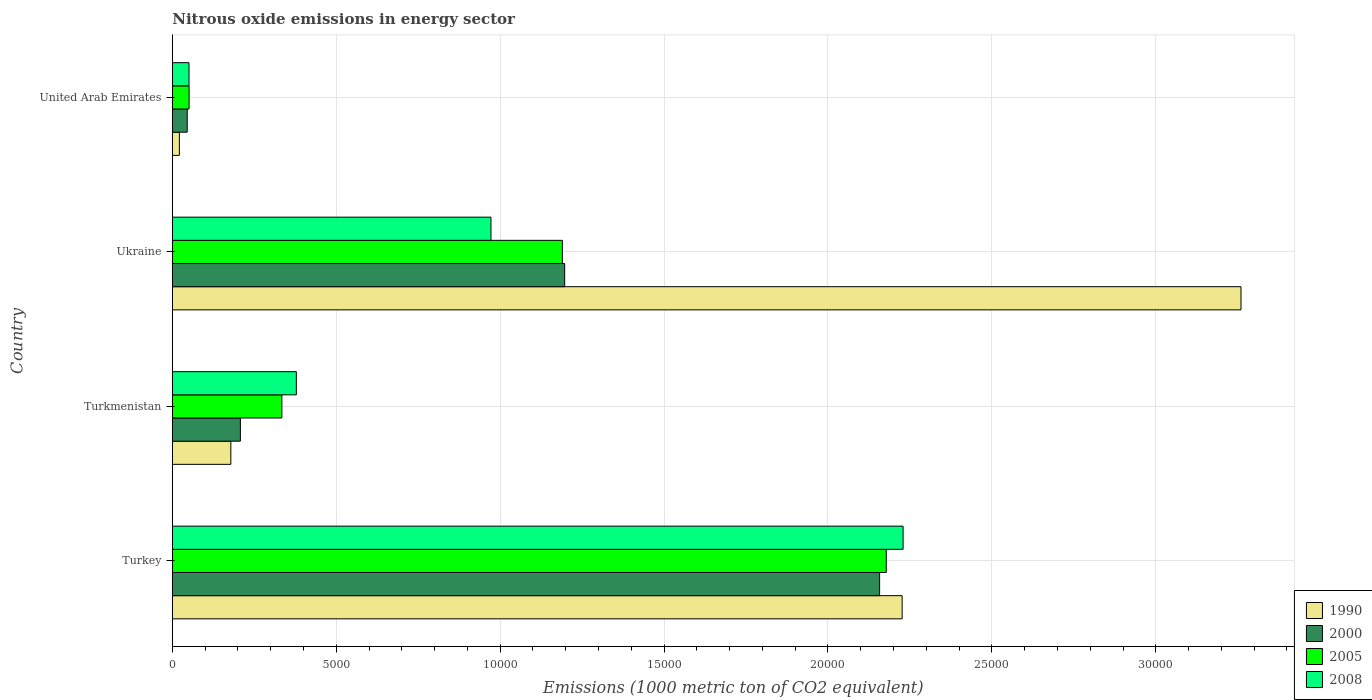How many different coloured bars are there?
Your answer should be compact. 4. Are the number of bars per tick equal to the number of legend labels?
Provide a short and direct response. Yes. How many bars are there on the 1st tick from the top?
Your answer should be very brief. 4. How many bars are there on the 2nd tick from the bottom?
Your response must be concise. 4. What is the label of the 3rd group of bars from the top?
Provide a succinct answer. Turkmenistan. In how many cases, is the number of bars for a given country not equal to the number of legend labels?
Ensure brevity in your answer.  0. What is the amount of nitrous oxide emitted in 2000 in Turkey?
Provide a short and direct response. 2.16e+04. Across all countries, what is the maximum amount of nitrous oxide emitted in 2008?
Ensure brevity in your answer.  2.23e+04. Across all countries, what is the minimum amount of nitrous oxide emitted in 1990?
Make the answer very short. 214.5. In which country was the amount of nitrous oxide emitted in 1990 maximum?
Ensure brevity in your answer.  Ukraine. In which country was the amount of nitrous oxide emitted in 2008 minimum?
Keep it short and to the point. United Arab Emirates. What is the total amount of nitrous oxide emitted in 2000 in the graph?
Keep it short and to the point. 3.61e+04. What is the difference between the amount of nitrous oxide emitted in 2000 in Ukraine and that in United Arab Emirates?
Offer a very short reply. 1.15e+04. What is the difference between the amount of nitrous oxide emitted in 2005 in Ukraine and the amount of nitrous oxide emitted in 2000 in Turkmenistan?
Offer a terse response. 9822.2. What is the average amount of nitrous oxide emitted in 1990 per country?
Provide a short and direct response. 1.42e+04. What is the difference between the amount of nitrous oxide emitted in 1990 and amount of nitrous oxide emitted in 2000 in Turkmenistan?
Ensure brevity in your answer.  -290.8. What is the ratio of the amount of nitrous oxide emitted in 2000 in Turkmenistan to that in United Arab Emirates?
Your answer should be very brief. 4.58. Is the amount of nitrous oxide emitted in 2005 in Turkey less than that in United Arab Emirates?
Provide a succinct answer. No. What is the difference between the highest and the second highest amount of nitrous oxide emitted in 1990?
Keep it short and to the point. 1.03e+04. What is the difference between the highest and the lowest amount of nitrous oxide emitted in 1990?
Provide a succinct answer. 3.24e+04. In how many countries, is the amount of nitrous oxide emitted in 2005 greater than the average amount of nitrous oxide emitted in 2005 taken over all countries?
Provide a succinct answer. 2. Is the sum of the amount of nitrous oxide emitted in 1990 in Turkmenistan and United Arab Emirates greater than the maximum amount of nitrous oxide emitted in 2005 across all countries?
Provide a succinct answer. No. Is it the case that in every country, the sum of the amount of nitrous oxide emitted in 2005 and amount of nitrous oxide emitted in 2000 is greater than the sum of amount of nitrous oxide emitted in 2008 and amount of nitrous oxide emitted in 1990?
Offer a very short reply. No. How many bars are there?
Your answer should be compact. 16. How many countries are there in the graph?
Your answer should be very brief. 4. What is the difference between two consecutive major ticks on the X-axis?
Provide a succinct answer. 5000. How are the legend labels stacked?
Provide a short and direct response. Vertical. What is the title of the graph?
Your response must be concise. Nitrous oxide emissions in energy sector. What is the label or title of the X-axis?
Provide a succinct answer. Emissions (1000 metric ton of CO2 equivalent). What is the Emissions (1000 metric ton of CO2 equivalent) in 1990 in Turkey?
Offer a terse response. 2.23e+04. What is the Emissions (1000 metric ton of CO2 equivalent) in 2000 in Turkey?
Your response must be concise. 2.16e+04. What is the Emissions (1000 metric ton of CO2 equivalent) of 2005 in Turkey?
Your answer should be very brief. 2.18e+04. What is the Emissions (1000 metric ton of CO2 equivalent) of 2008 in Turkey?
Your answer should be compact. 2.23e+04. What is the Emissions (1000 metric ton of CO2 equivalent) in 1990 in Turkmenistan?
Your response must be concise. 1784.5. What is the Emissions (1000 metric ton of CO2 equivalent) in 2000 in Turkmenistan?
Offer a terse response. 2075.3. What is the Emissions (1000 metric ton of CO2 equivalent) of 2005 in Turkmenistan?
Provide a succinct answer. 3341.3. What is the Emissions (1000 metric ton of CO2 equivalent) in 2008 in Turkmenistan?
Your answer should be compact. 3782.4. What is the Emissions (1000 metric ton of CO2 equivalent) in 1990 in Ukraine?
Provide a short and direct response. 3.26e+04. What is the Emissions (1000 metric ton of CO2 equivalent) in 2000 in Ukraine?
Provide a succinct answer. 1.20e+04. What is the Emissions (1000 metric ton of CO2 equivalent) of 2005 in Ukraine?
Your answer should be compact. 1.19e+04. What is the Emissions (1000 metric ton of CO2 equivalent) in 2008 in Ukraine?
Your response must be concise. 9719.1. What is the Emissions (1000 metric ton of CO2 equivalent) in 1990 in United Arab Emirates?
Your answer should be compact. 214.5. What is the Emissions (1000 metric ton of CO2 equivalent) in 2000 in United Arab Emirates?
Provide a short and direct response. 453.6. What is the Emissions (1000 metric ton of CO2 equivalent) of 2005 in United Arab Emirates?
Give a very brief answer. 510.2. What is the Emissions (1000 metric ton of CO2 equivalent) of 2008 in United Arab Emirates?
Your answer should be compact. 507.7. Across all countries, what is the maximum Emissions (1000 metric ton of CO2 equivalent) in 1990?
Your answer should be compact. 3.26e+04. Across all countries, what is the maximum Emissions (1000 metric ton of CO2 equivalent) of 2000?
Provide a short and direct response. 2.16e+04. Across all countries, what is the maximum Emissions (1000 metric ton of CO2 equivalent) of 2005?
Your answer should be very brief. 2.18e+04. Across all countries, what is the maximum Emissions (1000 metric ton of CO2 equivalent) in 2008?
Provide a short and direct response. 2.23e+04. Across all countries, what is the minimum Emissions (1000 metric ton of CO2 equivalent) in 1990?
Give a very brief answer. 214.5. Across all countries, what is the minimum Emissions (1000 metric ton of CO2 equivalent) in 2000?
Your answer should be very brief. 453.6. Across all countries, what is the minimum Emissions (1000 metric ton of CO2 equivalent) in 2005?
Provide a succinct answer. 510.2. Across all countries, what is the minimum Emissions (1000 metric ton of CO2 equivalent) in 2008?
Your answer should be compact. 507.7. What is the total Emissions (1000 metric ton of CO2 equivalent) in 1990 in the graph?
Your answer should be very brief. 5.69e+04. What is the total Emissions (1000 metric ton of CO2 equivalent) in 2000 in the graph?
Offer a very short reply. 3.61e+04. What is the total Emissions (1000 metric ton of CO2 equivalent) of 2005 in the graph?
Give a very brief answer. 3.75e+04. What is the total Emissions (1000 metric ton of CO2 equivalent) in 2008 in the graph?
Offer a terse response. 3.63e+04. What is the difference between the Emissions (1000 metric ton of CO2 equivalent) of 1990 in Turkey and that in Turkmenistan?
Ensure brevity in your answer.  2.05e+04. What is the difference between the Emissions (1000 metric ton of CO2 equivalent) of 2000 in Turkey and that in Turkmenistan?
Your response must be concise. 1.95e+04. What is the difference between the Emissions (1000 metric ton of CO2 equivalent) in 2005 in Turkey and that in Turkmenistan?
Keep it short and to the point. 1.84e+04. What is the difference between the Emissions (1000 metric ton of CO2 equivalent) in 2008 in Turkey and that in Turkmenistan?
Provide a short and direct response. 1.85e+04. What is the difference between the Emissions (1000 metric ton of CO2 equivalent) in 1990 in Turkey and that in Ukraine?
Your response must be concise. -1.03e+04. What is the difference between the Emissions (1000 metric ton of CO2 equivalent) in 2000 in Turkey and that in Ukraine?
Ensure brevity in your answer.  9607.4. What is the difference between the Emissions (1000 metric ton of CO2 equivalent) in 2005 in Turkey and that in Ukraine?
Your answer should be compact. 9880.3. What is the difference between the Emissions (1000 metric ton of CO2 equivalent) in 2008 in Turkey and that in Ukraine?
Offer a terse response. 1.26e+04. What is the difference between the Emissions (1000 metric ton of CO2 equivalent) in 1990 in Turkey and that in United Arab Emirates?
Keep it short and to the point. 2.20e+04. What is the difference between the Emissions (1000 metric ton of CO2 equivalent) in 2000 in Turkey and that in United Arab Emirates?
Make the answer very short. 2.11e+04. What is the difference between the Emissions (1000 metric ton of CO2 equivalent) in 2005 in Turkey and that in United Arab Emirates?
Offer a very short reply. 2.13e+04. What is the difference between the Emissions (1000 metric ton of CO2 equivalent) of 2008 in Turkey and that in United Arab Emirates?
Offer a very short reply. 2.18e+04. What is the difference between the Emissions (1000 metric ton of CO2 equivalent) of 1990 in Turkmenistan and that in Ukraine?
Ensure brevity in your answer.  -3.08e+04. What is the difference between the Emissions (1000 metric ton of CO2 equivalent) of 2000 in Turkmenistan and that in Ukraine?
Provide a succinct answer. -9892.6. What is the difference between the Emissions (1000 metric ton of CO2 equivalent) of 2005 in Turkmenistan and that in Ukraine?
Your response must be concise. -8556.2. What is the difference between the Emissions (1000 metric ton of CO2 equivalent) of 2008 in Turkmenistan and that in Ukraine?
Keep it short and to the point. -5936.7. What is the difference between the Emissions (1000 metric ton of CO2 equivalent) of 1990 in Turkmenistan and that in United Arab Emirates?
Ensure brevity in your answer.  1570. What is the difference between the Emissions (1000 metric ton of CO2 equivalent) in 2000 in Turkmenistan and that in United Arab Emirates?
Make the answer very short. 1621.7. What is the difference between the Emissions (1000 metric ton of CO2 equivalent) in 2005 in Turkmenistan and that in United Arab Emirates?
Keep it short and to the point. 2831.1. What is the difference between the Emissions (1000 metric ton of CO2 equivalent) of 2008 in Turkmenistan and that in United Arab Emirates?
Provide a succinct answer. 3274.7. What is the difference between the Emissions (1000 metric ton of CO2 equivalent) of 1990 in Ukraine and that in United Arab Emirates?
Ensure brevity in your answer.  3.24e+04. What is the difference between the Emissions (1000 metric ton of CO2 equivalent) of 2000 in Ukraine and that in United Arab Emirates?
Your answer should be very brief. 1.15e+04. What is the difference between the Emissions (1000 metric ton of CO2 equivalent) in 2005 in Ukraine and that in United Arab Emirates?
Your answer should be very brief. 1.14e+04. What is the difference between the Emissions (1000 metric ton of CO2 equivalent) of 2008 in Ukraine and that in United Arab Emirates?
Keep it short and to the point. 9211.4. What is the difference between the Emissions (1000 metric ton of CO2 equivalent) of 1990 in Turkey and the Emissions (1000 metric ton of CO2 equivalent) of 2000 in Turkmenistan?
Provide a succinct answer. 2.02e+04. What is the difference between the Emissions (1000 metric ton of CO2 equivalent) in 1990 in Turkey and the Emissions (1000 metric ton of CO2 equivalent) in 2005 in Turkmenistan?
Ensure brevity in your answer.  1.89e+04. What is the difference between the Emissions (1000 metric ton of CO2 equivalent) in 1990 in Turkey and the Emissions (1000 metric ton of CO2 equivalent) in 2008 in Turkmenistan?
Provide a short and direct response. 1.85e+04. What is the difference between the Emissions (1000 metric ton of CO2 equivalent) of 2000 in Turkey and the Emissions (1000 metric ton of CO2 equivalent) of 2005 in Turkmenistan?
Make the answer very short. 1.82e+04. What is the difference between the Emissions (1000 metric ton of CO2 equivalent) of 2000 in Turkey and the Emissions (1000 metric ton of CO2 equivalent) of 2008 in Turkmenistan?
Offer a terse response. 1.78e+04. What is the difference between the Emissions (1000 metric ton of CO2 equivalent) of 2005 in Turkey and the Emissions (1000 metric ton of CO2 equivalent) of 2008 in Turkmenistan?
Provide a succinct answer. 1.80e+04. What is the difference between the Emissions (1000 metric ton of CO2 equivalent) in 1990 in Turkey and the Emissions (1000 metric ton of CO2 equivalent) in 2000 in Ukraine?
Ensure brevity in your answer.  1.03e+04. What is the difference between the Emissions (1000 metric ton of CO2 equivalent) of 1990 in Turkey and the Emissions (1000 metric ton of CO2 equivalent) of 2005 in Ukraine?
Offer a very short reply. 1.04e+04. What is the difference between the Emissions (1000 metric ton of CO2 equivalent) of 1990 in Turkey and the Emissions (1000 metric ton of CO2 equivalent) of 2008 in Ukraine?
Ensure brevity in your answer.  1.25e+04. What is the difference between the Emissions (1000 metric ton of CO2 equivalent) of 2000 in Turkey and the Emissions (1000 metric ton of CO2 equivalent) of 2005 in Ukraine?
Provide a short and direct response. 9677.8. What is the difference between the Emissions (1000 metric ton of CO2 equivalent) of 2000 in Turkey and the Emissions (1000 metric ton of CO2 equivalent) of 2008 in Ukraine?
Give a very brief answer. 1.19e+04. What is the difference between the Emissions (1000 metric ton of CO2 equivalent) in 2005 in Turkey and the Emissions (1000 metric ton of CO2 equivalent) in 2008 in Ukraine?
Ensure brevity in your answer.  1.21e+04. What is the difference between the Emissions (1000 metric ton of CO2 equivalent) of 1990 in Turkey and the Emissions (1000 metric ton of CO2 equivalent) of 2000 in United Arab Emirates?
Your answer should be very brief. 2.18e+04. What is the difference between the Emissions (1000 metric ton of CO2 equivalent) in 1990 in Turkey and the Emissions (1000 metric ton of CO2 equivalent) in 2005 in United Arab Emirates?
Your answer should be very brief. 2.18e+04. What is the difference between the Emissions (1000 metric ton of CO2 equivalent) of 1990 in Turkey and the Emissions (1000 metric ton of CO2 equivalent) of 2008 in United Arab Emirates?
Offer a terse response. 2.18e+04. What is the difference between the Emissions (1000 metric ton of CO2 equivalent) in 2000 in Turkey and the Emissions (1000 metric ton of CO2 equivalent) in 2005 in United Arab Emirates?
Your answer should be very brief. 2.11e+04. What is the difference between the Emissions (1000 metric ton of CO2 equivalent) of 2000 in Turkey and the Emissions (1000 metric ton of CO2 equivalent) of 2008 in United Arab Emirates?
Provide a short and direct response. 2.11e+04. What is the difference between the Emissions (1000 metric ton of CO2 equivalent) in 2005 in Turkey and the Emissions (1000 metric ton of CO2 equivalent) in 2008 in United Arab Emirates?
Offer a very short reply. 2.13e+04. What is the difference between the Emissions (1000 metric ton of CO2 equivalent) in 1990 in Turkmenistan and the Emissions (1000 metric ton of CO2 equivalent) in 2000 in Ukraine?
Give a very brief answer. -1.02e+04. What is the difference between the Emissions (1000 metric ton of CO2 equivalent) in 1990 in Turkmenistan and the Emissions (1000 metric ton of CO2 equivalent) in 2005 in Ukraine?
Ensure brevity in your answer.  -1.01e+04. What is the difference between the Emissions (1000 metric ton of CO2 equivalent) of 1990 in Turkmenistan and the Emissions (1000 metric ton of CO2 equivalent) of 2008 in Ukraine?
Provide a short and direct response. -7934.6. What is the difference between the Emissions (1000 metric ton of CO2 equivalent) of 2000 in Turkmenistan and the Emissions (1000 metric ton of CO2 equivalent) of 2005 in Ukraine?
Your answer should be compact. -9822.2. What is the difference between the Emissions (1000 metric ton of CO2 equivalent) of 2000 in Turkmenistan and the Emissions (1000 metric ton of CO2 equivalent) of 2008 in Ukraine?
Make the answer very short. -7643.8. What is the difference between the Emissions (1000 metric ton of CO2 equivalent) in 2005 in Turkmenistan and the Emissions (1000 metric ton of CO2 equivalent) in 2008 in Ukraine?
Give a very brief answer. -6377.8. What is the difference between the Emissions (1000 metric ton of CO2 equivalent) in 1990 in Turkmenistan and the Emissions (1000 metric ton of CO2 equivalent) in 2000 in United Arab Emirates?
Your answer should be compact. 1330.9. What is the difference between the Emissions (1000 metric ton of CO2 equivalent) of 1990 in Turkmenistan and the Emissions (1000 metric ton of CO2 equivalent) of 2005 in United Arab Emirates?
Your answer should be compact. 1274.3. What is the difference between the Emissions (1000 metric ton of CO2 equivalent) in 1990 in Turkmenistan and the Emissions (1000 metric ton of CO2 equivalent) in 2008 in United Arab Emirates?
Provide a succinct answer. 1276.8. What is the difference between the Emissions (1000 metric ton of CO2 equivalent) of 2000 in Turkmenistan and the Emissions (1000 metric ton of CO2 equivalent) of 2005 in United Arab Emirates?
Provide a succinct answer. 1565.1. What is the difference between the Emissions (1000 metric ton of CO2 equivalent) in 2000 in Turkmenistan and the Emissions (1000 metric ton of CO2 equivalent) in 2008 in United Arab Emirates?
Offer a terse response. 1567.6. What is the difference between the Emissions (1000 metric ton of CO2 equivalent) in 2005 in Turkmenistan and the Emissions (1000 metric ton of CO2 equivalent) in 2008 in United Arab Emirates?
Provide a succinct answer. 2833.6. What is the difference between the Emissions (1000 metric ton of CO2 equivalent) of 1990 in Ukraine and the Emissions (1000 metric ton of CO2 equivalent) of 2000 in United Arab Emirates?
Your response must be concise. 3.21e+04. What is the difference between the Emissions (1000 metric ton of CO2 equivalent) of 1990 in Ukraine and the Emissions (1000 metric ton of CO2 equivalent) of 2005 in United Arab Emirates?
Provide a succinct answer. 3.21e+04. What is the difference between the Emissions (1000 metric ton of CO2 equivalent) of 1990 in Ukraine and the Emissions (1000 metric ton of CO2 equivalent) of 2008 in United Arab Emirates?
Your answer should be compact. 3.21e+04. What is the difference between the Emissions (1000 metric ton of CO2 equivalent) in 2000 in Ukraine and the Emissions (1000 metric ton of CO2 equivalent) in 2005 in United Arab Emirates?
Your answer should be compact. 1.15e+04. What is the difference between the Emissions (1000 metric ton of CO2 equivalent) in 2000 in Ukraine and the Emissions (1000 metric ton of CO2 equivalent) in 2008 in United Arab Emirates?
Offer a very short reply. 1.15e+04. What is the difference between the Emissions (1000 metric ton of CO2 equivalent) of 2005 in Ukraine and the Emissions (1000 metric ton of CO2 equivalent) of 2008 in United Arab Emirates?
Keep it short and to the point. 1.14e+04. What is the average Emissions (1000 metric ton of CO2 equivalent) in 1990 per country?
Your response must be concise. 1.42e+04. What is the average Emissions (1000 metric ton of CO2 equivalent) of 2000 per country?
Offer a terse response. 9018.02. What is the average Emissions (1000 metric ton of CO2 equivalent) in 2005 per country?
Offer a terse response. 9381.7. What is the average Emissions (1000 metric ton of CO2 equivalent) in 2008 per country?
Provide a succinct answer. 9075.23. What is the difference between the Emissions (1000 metric ton of CO2 equivalent) in 1990 and Emissions (1000 metric ton of CO2 equivalent) in 2000 in Turkey?
Offer a very short reply. 687.6. What is the difference between the Emissions (1000 metric ton of CO2 equivalent) of 1990 and Emissions (1000 metric ton of CO2 equivalent) of 2005 in Turkey?
Your answer should be very brief. 485.1. What is the difference between the Emissions (1000 metric ton of CO2 equivalent) in 1990 and Emissions (1000 metric ton of CO2 equivalent) in 2008 in Turkey?
Provide a short and direct response. -28.8. What is the difference between the Emissions (1000 metric ton of CO2 equivalent) in 2000 and Emissions (1000 metric ton of CO2 equivalent) in 2005 in Turkey?
Give a very brief answer. -202.5. What is the difference between the Emissions (1000 metric ton of CO2 equivalent) of 2000 and Emissions (1000 metric ton of CO2 equivalent) of 2008 in Turkey?
Give a very brief answer. -716.4. What is the difference between the Emissions (1000 metric ton of CO2 equivalent) in 2005 and Emissions (1000 metric ton of CO2 equivalent) in 2008 in Turkey?
Your response must be concise. -513.9. What is the difference between the Emissions (1000 metric ton of CO2 equivalent) of 1990 and Emissions (1000 metric ton of CO2 equivalent) of 2000 in Turkmenistan?
Your response must be concise. -290.8. What is the difference between the Emissions (1000 metric ton of CO2 equivalent) of 1990 and Emissions (1000 metric ton of CO2 equivalent) of 2005 in Turkmenistan?
Provide a short and direct response. -1556.8. What is the difference between the Emissions (1000 metric ton of CO2 equivalent) of 1990 and Emissions (1000 metric ton of CO2 equivalent) of 2008 in Turkmenistan?
Your answer should be very brief. -1997.9. What is the difference between the Emissions (1000 metric ton of CO2 equivalent) of 2000 and Emissions (1000 metric ton of CO2 equivalent) of 2005 in Turkmenistan?
Give a very brief answer. -1266. What is the difference between the Emissions (1000 metric ton of CO2 equivalent) of 2000 and Emissions (1000 metric ton of CO2 equivalent) of 2008 in Turkmenistan?
Provide a succinct answer. -1707.1. What is the difference between the Emissions (1000 metric ton of CO2 equivalent) of 2005 and Emissions (1000 metric ton of CO2 equivalent) of 2008 in Turkmenistan?
Offer a very short reply. -441.1. What is the difference between the Emissions (1000 metric ton of CO2 equivalent) of 1990 and Emissions (1000 metric ton of CO2 equivalent) of 2000 in Ukraine?
Provide a succinct answer. 2.06e+04. What is the difference between the Emissions (1000 metric ton of CO2 equivalent) of 1990 and Emissions (1000 metric ton of CO2 equivalent) of 2005 in Ukraine?
Keep it short and to the point. 2.07e+04. What is the difference between the Emissions (1000 metric ton of CO2 equivalent) of 1990 and Emissions (1000 metric ton of CO2 equivalent) of 2008 in Ukraine?
Make the answer very short. 2.29e+04. What is the difference between the Emissions (1000 metric ton of CO2 equivalent) of 2000 and Emissions (1000 metric ton of CO2 equivalent) of 2005 in Ukraine?
Ensure brevity in your answer.  70.4. What is the difference between the Emissions (1000 metric ton of CO2 equivalent) of 2000 and Emissions (1000 metric ton of CO2 equivalent) of 2008 in Ukraine?
Your answer should be compact. 2248.8. What is the difference between the Emissions (1000 metric ton of CO2 equivalent) of 2005 and Emissions (1000 metric ton of CO2 equivalent) of 2008 in Ukraine?
Provide a short and direct response. 2178.4. What is the difference between the Emissions (1000 metric ton of CO2 equivalent) in 1990 and Emissions (1000 metric ton of CO2 equivalent) in 2000 in United Arab Emirates?
Your answer should be very brief. -239.1. What is the difference between the Emissions (1000 metric ton of CO2 equivalent) in 1990 and Emissions (1000 metric ton of CO2 equivalent) in 2005 in United Arab Emirates?
Make the answer very short. -295.7. What is the difference between the Emissions (1000 metric ton of CO2 equivalent) of 1990 and Emissions (1000 metric ton of CO2 equivalent) of 2008 in United Arab Emirates?
Your response must be concise. -293.2. What is the difference between the Emissions (1000 metric ton of CO2 equivalent) of 2000 and Emissions (1000 metric ton of CO2 equivalent) of 2005 in United Arab Emirates?
Your response must be concise. -56.6. What is the difference between the Emissions (1000 metric ton of CO2 equivalent) of 2000 and Emissions (1000 metric ton of CO2 equivalent) of 2008 in United Arab Emirates?
Your answer should be compact. -54.1. What is the difference between the Emissions (1000 metric ton of CO2 equivalent) of 2005 and Emissions (1000 metric ton of CO2 equivalent) of 2008 in United Arab Emirates?
Provide a short and direct response. 2.5. What is the ratio of the Emissions (1000 metric ton of CO2 equivalent) in 1990 in Turkey to that in Turkmenistan?
Ensure brevity in your answer.  12.48. What is the ratio of the Emissions (1000 metric ton of CO2 equivalent) in 2000 in Turkey to that in Turkmenistan?
Offer a very short reply. 10.4. What is the ratio of the Emissions (1000 metric ton of CO2 equivalent) in 2005 in Turkey to that in Turkmenistan?
Your response must be concise. 6.52. What is the ratio of the Emissions (1000 metric ton of CO2 equivalent) in 2008 in Turkey to that in Turkmenistan?
Ensure brevity in your answer.  5.89. What is the ratio of the Emissions (1000 metric ton of CO2 equivalent) in 1990 in Turkey to that in Ukraine?
Your answer should be very brief. 0.68. What is the ratio of the Emissions (1000 metric ton of CO2 equivalent) in 2000 in Turkey to that in Ukraine?
Offer a very short reply. 1.8. What is the ratio of the Emissions (1000 metric ton of CO2 equivalent) in 2005 in Turkey to that in Ukraine?
Your answer should be very brief. 1.83. What is the ratio of the Emissions (1000 metric ton of CO2 equivalent) of 2008 in Turkey to that in Ukraine?
Offer a terse response. 2.29. What is the ratio of the Emissions (1000 metric ton of CO2 equivalent) of 1990 in Turkey to that in United Arab Emirates?
Keep it short and to the point. 103.79. What is the ratio of the Emissions (1000 metric ton of CO2 equivalent) of 2000 in Turkey to that in United Arab Emirates?
Provide a short and direct response. 47.56. What is the ratio of the Emissions (1000 metric ton of CO2 equivalent) in 2005 in Turkey to that in United Arab Emirates?
Keep it short and to the point. 42.68. What is the ratio of the Emissions (1000 metric ton of CO2 equivalent) in 2008 in Turkey to that in United Arab Emirates?
Offer a terse response. 43.91. What is the ratio of the Emissions (1000 metric ton of CO2 equivalent) in 1990 in Turkmenistan to that in Ukraine?
Offer a terse response. 0.05. What is the ratio of the Emissions (1000 metric ton of CO2 equivalent) of 2000 in Turkmenistan to that in Ukraine?
Ensure brevity in your answer.  0.17. What is the ratio of the Emissions (1000 metric ton of CO2 equivalent) in 2005 in Turkmenistan to that in Ukraine?
Your answer should be very brief. 0.28. What is the ratio of the Emissions (1000 metric ton of CO2 equivalent) of 2008 in Turkmenistan to that in Ukraine?
Keep it short and to the point. 0.39. What is the ratio of the Emissions (1000 metric ton of CO2 equivalent) of 1990 in Turkmenistan to that in United Arab Emirates?
Provide a short and direct response. 8.32. What is the ratio of the Emissions (1000 metric ton of CO2 equivalent) of 2000 in Turkmenistan to that in United Arab Emirates?
Make the answer very short. 4.58. What is the ratio of the Emissions (1000 metric ton of CO2 equivalent) of 2005 in Turkmenistan to that in United Arab Emirates?
Offer a very short reply. 6.55. What is the ratio of the Emissions (1000 metric ton of CO2 equivalent) in 2008 in Turkmenistan to that in United Arab Emirates?
Your answer should be very brief. 7.45. What is the ratio of the Emissions (1000 metric ton of CO2 equivalent) of 1990 in Ukraine to that in United Arab Emirates?
Offer a very short reply. 151.98. What is the ratio of the Emissions (1000 metric ton of CO2 equivalent) of 2000 in Ukraine to that in United Arab Emirates?
Your response must be concise. 26.38. What is the ratio of the Emissions (1000 metric ton of CO2 equivalent) of 2005 in Ukraine to that in United Arab Emirates?
Your response must be concise. 23.32. What is the ratio of the Emissions (1000 metric ton of CO2 equivalent) of 2008 in Ukraine to that in United Arab Emirates?
Keep it short and to the point. 19.14. What is the difference between the highest and the second highest Emissions (1000 metric ton of CO2 equivalent) in 1990?
Make the answer very short. 1.03e+04. What is the difference between the highest and the second highest Emissions (1000 metric ton of CO2 equivalent) of 2000?
Your answer should be compact. 9607.4. What is the difference between the highest and the second highest Emissions (1000 metric ton of CO2 equivalent) in 2005?
Give a very brief answer. 9880.3. What is the difference between the highest and the second highest Emissions (1000 metric ton of CO2 equivalent) of 2008?
Give a very brief answer. 1.26e+04. What is the difference between the highest and the lowest Emissions (1000 metric ton of CO2 equivalent) in 1990?
Your response must be concise. 3.24e+04. What is the difference between the highest and the lowest Emissions (1000 metric ton of CO2 equivalent) in 2000?
Ensure brevity in your answer.  2.11e+04. What is the difference between the highest and the lowest Emissions (1000 metric ton of CO2 equivalent) in 2005?
Offer a very short reply. 2.13e+04. What is the difference between the highest and the lowest Emissions (1000 metric ton of CO2 equivalent) of 2008?
Offer a terse response. 2.18e+04. 